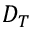<formula> <loc_0><loc_0><loc_500><loc_500>D _ { T }</formula> 